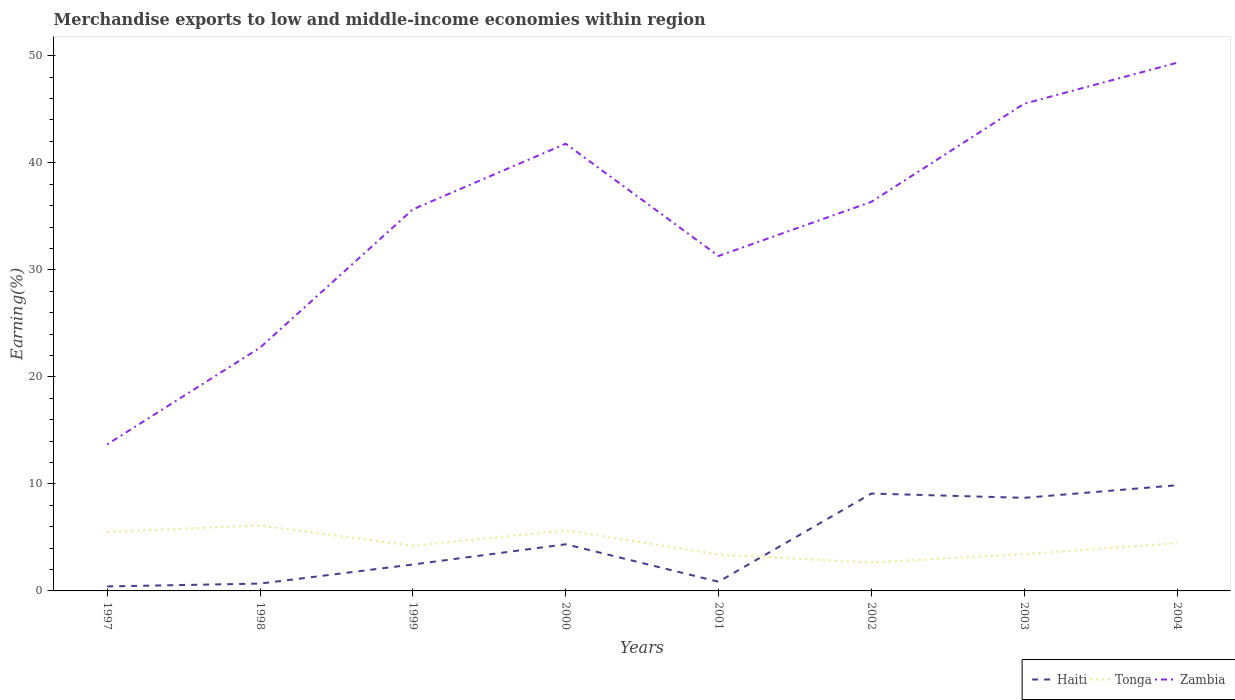Does the line corresponding to Tonga intersect with the line corresponding to Zambia?
Ensure brevity in your answer.  No. Is the number of lines equal to the number of legend labels?
Provide a short and direct response. Yes. Across all years, what is the maximum percentage of amount earned from merchandise exports in Tonga?
Give a very brief answer. 2.65. In which year was the percentage of amount earned from merchandise exports in Tonga maximum?
Make the answer very short. 2002. What is the total percentage of amount earned from merchandise exports in Haiti in the graph?
Ensure brevity in your answer.  -9.19. What is the difference between the highest and the second highest percentage of amount earned from merchandise exports in Haiti?
Give a very brief answer. 9.46. How many lines are there?
Offer a very short reply. 3. How many years are there in the graph?
Your answer should be very brief. 8. What is the difference between two consecutive major ticks on the Y-axis?
Keep it short and to the point. 10. Are the values on the major ticks of Y-axis written in scientific E-notation?
Make the answer very short. No. Where does the legend appear in the graph?
Give a very brief answer. Bottom right. How many legend labels are there?
Keep it short and to the point. 3. How are the legend labels stacked?
Your answer should be compact. Horizontal. What is the title of the graph?
Ensure brevity in your answer.  Merchandise exports to low and middle-income economies within region. Does "United Arab Emirates" appear as one of the legend labels in the graph?
Offer a very short reply. No. What is the label or title of the X-axis?
Your answer should be very brief. Years. What is the label or title of the Y-axis?
Ensure brevity in your answer.  Earning(%). What is the Earning(%) of Haiti in 1997?
Ensure brevity in your answer.  0.42. What is the Earning(%) of Tonga in 1997?
Provide a short and direct response. 5.51. What is the Earning(%) of Zambia in 1997?
Ensure brevity in your answer.  13.69. What is the Earning(%) of Haiti in 1998?
Provide a succinct answer. 0.69. What is the Earning(%) in Tonga in 1998?
Ensure brevity in your answer.  6.12. What is the Earning(%) in Zambia in 1998?
Offer a terse response. 22.73. What is the Earning(%) in Haiti in 1999?
Make the answer very short. 2.47. What is the Earning(%) of Tonga in 1999?
Provide a short and direct response. 4.22. What is the Earning(%) of Zambia in 1999?
Give a very brief answer. 35.65. What is the Earning(%) of Haiti in 2000?
Your answer should be compact. 4.36. What is the Earning(%) in Tonga in 2000?
Your answer should be very brief. 5.66. What is the Earning(%) of Zambia in 2000?
Your answer should be very brief. 41.78. What is the Earning(%) in Haiti in 2001?
Your response must be concise. 0.86. What is the Earning(%) in Tonga in 2001?
Provide a short and direct response. 3.4. What is the Earning(%) of Zambia in 2001?
Your response must be concise. 31.29. What is the Earning(%) of Haiti in 2002?
Your answer should be compact. 9.1. What is the Earning(%) of Tonga in 2002?
Provide a succinct answer. 2.65. What is the Earning(%) in Zambia in 2002?
Provide a succinct answer. 36.35. What is the Earning(%) in Haiti in 2003?
Offer a very short reply. 8.7. What is the Earning(%) in Tonga in 2003?
Provide a succinct answer. 3.44. What is the Earning(%) in Zambia in 2003?
Your response must be concise. 45.52. What is the Earning(%) of Haiti in 2004?
Your answer should be very brief. 9.87. What is the Earning(%) in Tonga in 2004?
Your response must be concise. 4.46. What is the Earning(%) of Zambia in 2004?
Your response must be concise. 49.34. Across all years, what is the maximum Earning(%) in Haiti?
Ensure brevity in your answer.  9.87. Across all years, what is the maximum Earning(%) in Tonga?
Your answer should be compact. 6.12. Across all years, what is the maximum Earning(%) of Zambia?
Your response must be concise. 49.34. Across all years, what is the minimum Earning(%) of Haiti?
Provide a succinct answer. 0.42. Across all years, what is the minimum Earning(%) in Tonga?
Your response must be concise. 2.65. Across all years, what is the minimum Earning(%) of Zambia?
Provide a short and direct response. 13.69. What is the total Earning(%) of Haiti in the graph?
Your response must be concise. 36.46. What is the total Earning(%) of Tonga in the graph?
Offer a terse response. 35.46. What is the total Earning(%) in Zambia in the graph?
Your response must be concise. 276.35. What is the difference between the Earning(%) of Haiti in 1997 and that in 1998?
Give a very brief answer. -0.27. What is the difference between the Earning(%) of Tonga in 1997 and that in 1998?
Give a very brief answer. -0.62. What is the difference between the Earning(%) in Zambia in 1997 and that in 1998?
Give a very brief answer. -9.04. What is the difference between the Earning(%) in Haiti in 1997 and that in 1999?
Offer a terse response. -2.05. What is the difference between the Earning(%) of Tonga in 1997 and that in 1999?
Give a very brief answer. 1.29. What is the difference between the Earning(%) in Zambia in 1997 and that in 1999?
Provide a short and direct response. -21.96. What is the difference between the Earning(%) of Haiti in 1997 and that in 2000?
Offer a terse response. -3.94. What is the difference between the Earning(%) in Tonga in 1997 and that in 2000?
Ensure brevity in your answer.  -0.15. What is the difference between the Earning(%) in Zambia in 1997 and that in 2000?
Ensure brevity in your answer.  -28.09. What is the difference between the Earning(%) in Haiti in 1997 and that in 2001?
Offer a very short reply. -0.44. What is the difference between the Earning(%) in Tonga in 1997 and that in 2001?
Ensure brevity in your answer.  2.1. What is the difference between the Earning(%) of Zambia in 1997 and that in 2001?
Offer a terse response. -17.6. What is the difference between the Earning(%) in Haiti in 1997 and that in 2002?
Make the answer very short. -8.68. What is the difference between the Earning(%) of Tonga in 1997 and that in 2002?
Your answer should be compact. 2.86. What is the difference between the Earning(%) of Zambia in 1997 and that in 2002?
Ensure brevity in your answer.  -22.66. What is the difference between the Earning(%) of Haiti in 1997 and that in 2003?
Provide a succinct answer. -8.28. What is the difference between the Earning(%) in Tonga in 1997 and that in 2003?
Keep it short and to the point. 2.07. What is the difference between the Earning(%) in Zambia in 1997 and that in 2003?
Offer a very short reply. -31.83. What is the difference between the Earning(%) of Haiti in 1997 and that in 2004?
Your answer should be very brief. -9.46. What is the difference between the Earning(%) of Tonga in 1997 and that in 2004?
Give a very brief answer. 1.05. What is the difference between the Earning(%) of Zambia in 1997 and that in 2004?
Your answer should be compact. -35.66. What is the difference between the Earning(%) in Haiti in 1998 and that in 1999?
Provide a succinct answer. -1.78. What is the difference between the Earning(%) in Tonga in 1998 and that in 1999?
Your answer should be very brief. 1.9. What is the difference between the Earning(%) of Zambia in 1998 and that in 1999?
Offer a very short reply. -12.92. What is the difference between the Earning(%) in Haiti in 1998 and that in 2000?
Keep it short and to the point. -3.67. What is the difference between the Earning(%) of Tonga in 1998 and that in 2000?
Ensure brevity in your answer.  0.47. What is the difference between the Earning(%) of Zambia in 1998 and that in 2000?
Your answer should be very brief. -19.05. What is the difference between the Earning(%) in Haiti in 1998 and that in 2001?
Offer a very short reply. -0.17. What is the difference between the Earning(%) of Tonga in 1998 and that in 2001?
Your answer should be very brief. 2.72. What is the difference between the Earning(%) of Zambia in 1998 and that in 2001?
Your response must be concise. -8.57. What is the difference between the Earning(%) in Haiti in 1998 and that in 2002?
Offer a very short reply. -8.41. What is the difference between the Earning(%) of Tonga in 1998 and that in 2002?
Make the answer very short. 3.47. What is the difference between the Earning(%) in Zambia in 1998 and that in 2002?
Provide a short and direct response. -13.62. What is the difference between the Earning(%) in Haiti in 1998 and that in 2003?
Make the answer very short. -8.01. What is the difference between the Earning(%) of Tonga in 1998 and that in 2003?
Ensure brevity in your answer.  2.68. What is the difference between the Earning(%) in Zambia in 1998 and that in 2003?
Provide a succinct answer. -22.79. What is the difference between the Earning(%) in Haiti in 1998 and that in 2004?
Your response must be concise. -9.19. What is the difference between the Earning(%) in Tonga in 1998 and that in 2004?
Your answer should be compact. 1.66. What is the difference between the Earning(%) of Zambia in 1998 and that in 2004?
Make the answer very short. -26.62. What is the difference between the Earning(%) of Haiti in 1999 and that in 2000?
Provide a short and direct response. -1.89. What is the difference between the Earning(%) in Tonga in 1999 and that in 2000?
Your response must be concise. -1.44. What is the difference between the Earning(%) in Zambia in 1999 and that in 2000?
Ensure brevity in your answer.  -6.13. What is the difference between the Earning(%) of Haiti in 1999 and that in 2001?
Your answer should be very brief. 1.61. What is the difference between the Earning(%) in Tonga in 1999 and that in 2001?
Keep it short and to the point. 0.82. What is the difference between the Earning(%) of Zambia in 1999 and that in 2001?
Give a very brief answer. 4.36. What is the difference between the Earning(%) in Haiti in 1999 and that in 2002?
Offer a very short reply. -6.63. What is the difference between the Earning(%) of Tonga in 1999 and that in 2002?
Offer a terse response. 1.57. What is the difference between the Earning(%) in Zambia in 1999 and that in 2002?
Offer a very short reply. -0.7. What is the difference between the Earning(%) of Haiti in 1999 and that in 2003?
Offer a very short reply. -6.23. What is the difference between the Earning(%) in Tonga in 1999 and that in 2003?
Keep it short and to the point. 0.78. What is the difference between the Earning(%) in Zambia in 1999 and that in 2003?
Make the answer very short. -9.87. What is the difference between the Earning(%) of Haiti in 1999 and that in 2004?
Offer a terse response. -7.41. What is the difference between the Earning(%) in Tonga in 1999 and that in 2004?
Provide a short and direct response. -0.24. What is the difference between the Earning(%) of Zambia in 1999 and that in 2004?
Provide a short and direct response. -13.7. What is the difference between the Earning(%) of Haiti in 2000 and that in 2001?
Your answer should be very brief. 3.5. What is the difference between the Earning(%) in Tonga in 2000 and that in 2001?
Keep it short and to the point. 2.25. What is the difference between the Earning(%) of Zambia in 2000 and that in 2001?
Give a very brief answer. 10.49. What is the difference between the Earning(%) of Haiti in 2000 and that in 2002?
Your answer should be compact. -4.74. What is the difference between the Earning(%) of Tonga in 2000 and that in 2002?
Make the answer very short. 3.01. What is the difference between the Earning(%) in Zambia in 2000 and that in 2002?
Your answer should be very brief. 5.43. What is the difference between the Earning(%) in Haiti in 2000 and that in 2003?
Provide a succinct answer. -4.34. What is the difference between the Earning(%) of Tonga in 2000 and that in 2003?
Provide a short and direct response. 2.22. What is the difference between the Earning(%) of Zambia in 2000 and that in 2003?
Your response must be concise. -3.74. What is the difference between the Earning(%) of Haiti in 2000 and that in 2004?
Keep it short and to the point. -5.52. What is the difference between the Earning(%) of Tonga in 2000 and that in 2004?
Your response must be concise. 1.2. What is the difference between the Earning(%) of Zambia in 2000 and that in 2004?
Make the answer very short. -7.57. What is the difference between the Earning(%) of Haiti in 2001 and that in 2002?
Your answer should be compact. -8.24. What is the difference between the Earning(%) in Tonga in 2001 and that in 2002?
Offer a very short reply. 0.75. What is the difference between the Earning(%) of Zambia in 2001 and that in 2002?
Keep it short and to the point. -5.06. What is the difference between the Earning(%) in Haiti in 2001 and that in 2003?
Your answer should be very brief. -7.84. What is the difference between the Earning(%) in Tonga in 2001 and that in 2003?
Offer a very short reply. -0.04. What is the difference between the Earning(%) of Zambia in 2001 and that in 2003?
Your response must be concise. -14.23. What is the difference between the Earning(%) in Haiti in 2001 and that in 2004?
Your answer should be compact. -9.02. What is the difference between the Earning(%) of Tonga in 2001 and that in 2004?
Keep it short and to the point. -1.06. What is the difference between the Earning(%) in Zambia in 2001 and that in 2004?
Your response must be concise. -18.05. What is the difference between the Earning(%) of Haiti in 2002 and that in 2003?
Provide a short and direct response. 0.4. What is the difference between the Earning(%) in Tonga in 2002 and that in 2003?
Ensure brevity in your answer.  -0.79. What is the difference between the Earning(%) of Zambia in 2002 and that in 2003?
Your response must be concise. -9.17. What is the difference between the Earning(%) of Haiti in 2002 and that in 2004?
Offer a terse response. -0.78. What is the difference between the Earning(%) in Tonga in 2002 and that in 2004?
Ensure brevity in your answer.  -1.81. What is the difference between the Earning(%) of Zambia in 2002 and that in 2004?
Offer a terse response. -12.99. What is the difference between the Earning(%) of Haiti in 2003 and that in 2004?
Make the answer very short. -1.18. What is the difference between the Earning(%) in Tonga in 2003 and that in 2004?
Make the answer very short. -1.02. What is the difference between the Earning(%) in Zambia in 2003 and that in 2004?
Make the answer very short. -3.82. What is the difference between the Earning(%) of Haiti in 1997 and the Earning(%) of Tonga in 1998?
Keep it short and to the point. -5.7. What is the difference between the Earning(%) in Haiti in 1997 and the Earning(%) in Zambia in 1998?
Offer a very short reply. -22.31. What is the difference between the Earning(%) of Tonga in 1997 and the Earning(%) of Zambia in 1998?
Offer a terse response. -17.22. What is the difference between the Earning(%) in Haiti in 1997 and the Earning(%) in Tonga in 1999?
Ensure brevity in your answer.  -3.8. What is the difference between the Earning(%) in Haiti in 1997 and the Earning(%) in Zambia in 1999?
Ensure brevity in your answer.  -35.23. What is the difference between the Earning(%) in Tonga in 1997 and the Earning(%) in Zambia in 1999?
Keep it short and to the point. -30.14. What is the difference between the Earning(%) of Haiti in 1997 and the Earning(%) of Tonga in 2000?
Provide a short and direct response. -5.24. What is the difference between the Earning(%) in Haiti in 1997 and the Earning(%) in Zambia in 2000?
Offer a very short reply. -41.36. What is the difference between the Earning(%) of Tonga in 1997 and the Earning(%) of Zambia in 2000?
Your response must be concise. -36.27. What is the difference between the Earning(%) of Haiti in 1997 and the Earning(%) of Tonga in 2001?
Offer a terse response. -2.98. What is the difference between the Earning(%) in Haiti in 1997 and the Earning(%) in Zambia in 2001?
Your response must be concise. -30.87. What is the difference between the Earning(%) in Tonga in 1997 and the Earning(%) in Zambia in 2001?
Give a very brief answer. -25.79. What is the difference between the Earning(%) of Haiti in 1997 and the Earning(%) of Tonga in 2002?
Offer a terse response. -2.23. What is the difference between the Earning(%) of Haiti in 1997 and the Earning(%) of Zambia in 2002?
Your response must be concise. -35.93. What is the difference between the Earning(%) in Tonga in 1997 and the Earning(%) in Zambia in 2002?
Provide a short and direct response. -30.84. What is the difference between the Earning(%) of Haiti in 1997 and the Earning(%) of Tonga in 2003?
Your answer should be compact. -3.02. What is the difference between the Earning(%) in Haiti in 1997 and the Earning(%) in Zambia in 2003?
Provide a succinct answer. -45.1. What is the difference between the Earning(%) of Tonga in 1997 and the Earning(%) of Zambia in 2003?
Your response must be concise. -40.01. What is the difference between the Earning(%) in Haiti in 1997 and the Earning(%) in Tonga in 2004?
Offer a very short reply. -4.04. What is the difference between the Earning(%) in Haiti in 1997 and the Earning(%) in Zambia in 2004?
Offer a very short reply. -48.93. What is the difference between the Earning(%) of Tonga in 1997 and the Earning(%) of Zambia in 2004?
Give a very brief answer. -43.84. What is the difference between the Earning(%) of Haiti in 1998 and the Earning(%) of Tonga in 1999?
Your answer should be very brief. -3.53. What is the difference between the Earning(%) in Haiti in 1998 and the Earning(%) in Zambia in 1999?
Offer a very short reply. -34.96. What is the difference between the Earning(%) of Tonga in 1998 and the Earning(%) of Zambia in 1999?
Ensure brevity in your answer.  -29.53. What is the difference between the Earning(%) of Haiti in 1998 and the Earning(%) of Tonga in 2000?
Your response must be concise. -4.97. What is the difference between the Earning(%) in Haiti in 1998 and the Earning(%) in Zambia in 2000?
Provide a short and direct response. -41.09. What is the difference between the Earning(%) in Tonga in 1998 and the Earning(%) in Zambia in 2000?
Keep it short and to the point. -35.66. What is the difference between the Earning(%) of Haiti in 1998 and the Earning(%) of Tonga in 2001?
Keep it short and to the point. -2.72. What is the difference between the Earning(%) of Haiti in 1998 and the Earning(%) of Zambia in 2001?
Give a very brief answer. -30.61. What is the difference between the Earning(%) in Tonga in 1998 and the Earning(%) in Zambia in 2001?
Make the answer very short. -25.17. What is the difference between the Earning(%) in Haiti in 1998 and the Earning(%) in Tonga in 2002?
Make the answer very short. -1.97. What is the difference between the Earning(%) in Haiti in 1998 and the Earning(%) in Zambia in 2002?
Your answer should be very brief. -35.66. What is the difference between the Earning(%) of Tonga in 1998 and the Earning(%) of Zambia in 2002?
Give a very brief answer. -30.23. What is the difference between the Earning(%) in Haiti in 1998 and the Earning(%) in Tonga in 2003?
Your answer should be very brief. -2.75. What is the difference between the Earning(%) in Haiti in 1998 and the Earning(%) in Zambia in 2003?
Provide a short and direct response. -44.84. What is the difference between the Earning(%) in Tonga in 1998 and the Earning(%) in Zambia in 2003?
Your response must be concise. -39.4. What is the difference between the Earning(%) of Haiti in 1998 and the Earning(%) of Tonga in 2004?
Your answer should be compact. -3.77. What is the difference between the Earning(%) of Haiti in 1998 and the Earning(%) of Zambia in 2004?
Your response must be concise. -48.66. What is the difference between the Earning(%) in Tonga in 1998 and the Earning(%) in Zambia in 2004?
Offer a terse response. -43.22. What is the difference between the Earning(%) of Haiti in 1999 and the Earning(%) of Tonga in 2000?
Offer a very short reply. -3.19. What is the difference between the Earning(%) in Haiti in 1999 and the Earning(%) in Zambia in 2000?
Provide a succinct answer. -39.31. What is the difference between the Earning(%) of Tonga in 1999 and the Earning(%) of Zambia in 2000?
Give a very brief answer. -37.56. What is the difference between the Earning(%) in Haiti in 1999 and the Earning(%) in Tonga in 2001?
Make the answer very short. -0.93. What is the difference between the Earning(%) of Haiti in 1999 and the Earning(%) of Zambia in 2001?
Offer a terse response. -28.82. What is the difference between the Earning(%) of Tonga in 1999 and the Earning(%) of Zambia in 2001?
Give a very brief answer. -27.07. What is the difference between the Earning(%) of Haiti in 1999 and the Earning(%) of Tonga in 2002?
Make the answer very short. -0.18. What is the difference between the Earning(%) in Haiti in 1999 and the Earning(%) in Zambia in 2002?
Ensure brevity in your answer.  -33.88. What is the difference between the Earning(%) of Tonga in 1999 and the Earning(%) of Zambia in 2002?
Keep it short and to the point. -32.13. What is the difference between the Earning(%) in Haiti in 1999 and the Earning(%) in Tonga in 2003?
Make the answer very short. -0.97. What is the difference between the Earning(%) in Haiti in 1999 and the Earning(%) in Zambia in 2003?
Your response must be concise. -43.05. What is the difference between the Earning(%) of Tonga in 1999 and the Earning(%) of Zambia in 2003?
Your answer should be compact. -41.3. What is the difference between the Earning(%) of Haiti in 1999 and the Earning(%) of Tonga in 2004?
Provide a short and direct response. -1.99. What is the difference between the Earning(%) in Haiti in 1999 and the Earning(%) in Zambia in 2004?
Offer a very short reply. -46.88. What is the difference between the Earning(%) in Tonga in 1999 and the Earning(%) in Zambia in 2004?
Provide a short and direct response. -45.13. What is the difference between the Earning(%) of Haiti in 2000 and the Earning(%) of Tonga in 2001?
Offer a very short reply. 0.96. What is the difference between the Earning(%) in Haiti in 2000 and the Earning(%) in Zambia in 2001?
Make the answer very short. -26.93. What is the difference between the Earning(%) of Tonga in 2000 and the Earning(%) of Zambia in 2001?
Make the answer very short. -25.64. What is the difference between the Earning(%) of Haiti in 2000 and the Earning(%) of Tonga in 2002?
Offer a very short reply. 1.71. What is the difference between the Earning(%) in Haiti in 2000 and the Earning(%) in Zambia in 2002?
Your answer should be very brief. -31.99. What is the difference between the Earning(%) in Tonga in 2000 and the Earning(%) in Zambia in 2002?
Provide a short and direct response. -30.69. What is the difference between the Earning(%) of Haiti in 2000 and the Earning(%) of Tonga in 2003?
Offer a terse response. 0.92. What is the difference between the Earning(%) in Haiti in 2000 and the Earning(%) in Zambia in 2003?
Make the answer very short. -41.16. What is the difference between the Earning(%) of Tonga in 2000 and the Earning(%) of Zambia in 2003?
Give a very brief answer. -39.86. What is the difference between the Earning(%) of Haiti in 2000 and the Earning(%) of Tonga in 2004?
Your answer should be compact. -0.1. What is the difference between the Earning(%) in Haiti in 2000 and the Earning(%) in Zambia in 2004?
Make the answer very short. -44.99. What is the difference between the Earning(%) of Tonga in 2000 and the Earning(%) of Zambia in 2004?
Provide a succinct answer. -43.69. What is the difference between the Earning(%) of Haiti in 2001 and the Earning(%) of Tonga in 2002?
Your answer should be very brief. -1.79. What is the difference between the Earning(%) of Haiti in 2001 and the Earning(%) of Zambia in 2002?
Offer a terse response. -35.49. What is the difference between the Earning(%) of Tonga in 2001 and the Earning(%) of Zambia in 2002?
Your answer should be compact. -32.95. What is the difference between the Earning(%) in Haiti in 2001 and the Earning(%) in Tonga in 2003?
Offer a very short reply. -2.58. What is the difference between the Earning(%) in Haiti in 2001 and the Earning(%) in Zambia in 2003?
Make the answer very short. -44.66. What is the difference between the Earning(%) of Tonga in 2001 and the Earning(%) of Zambia in 2003?
Your answer should be very brief. -42.12. What is the difference between the Earning(%) in Haiti in 2001 and the Earning(%) in Tonga in 2004?
Offer a very short reply. -3.6. What is the difference between the Earning(%) of Haiti in 2001 and the Earning(%) of Zambia in 2004?
Keep it short and to the point. -48.49. What is the difference between the Earning(%) in Tonga in 2001 and the Earning(%) in Zambia in 2004?
Your response must be concise. -45.94. What is the difference between the Earning(%) in Haiti in 2002 and the Earning(%) in Tonga in 2003?
Offer a terse response. 5.66. What is the difference between the Earning(%) of Haiti in 2002 and the Earning(%) of Zambia in 2003?
Offer a terse response. -36.42. What is the difference between the Earning(%) in Tonga in 2002 and the Earning(%) in Zambia in 2003?
Your answer should be compact. -42.87. What is the difference between the Earning(%) in Haiti in 2002 and the Earning(%) in Tonga in 2004?
Ensure brevity in your answer.  4.64. What is the difference between the Earning(%) of Haiti in 2002 and the Earning(%) of Zambia in 2004?
Your response must be concise. -40.25. What is the difference between the Earning(%) in Tonga in 2002 and the Earning(%) in Zambia in 2004?
Provide a succinct answer. -46.69. What is the difference between the Earning(%) in Haiti in 2003 and the Earning(%) in Tonga in 2004?
Provide a succinct answer. 4.24. What is the difference between the Earning(%) of Haiti in 2003 and the Earning(%) of Zambia in 2004?
Provide a succinct answer. -40.65. What is the difference between the Earning(%) in Tonga in 2003 and the Earning(%) in Zambia in 2004?
Your response must be concise. -45.91. What is the average Earning(%) of Haiti per year?
Offer a very short reply. 4.56. What is the average Earning(%) in Tonga per year?
Give a very brief answer. 4.43. What is the average Earning(%) in Zambia per year?
Provide a succinct answer. 34.54. In the year 1997, what is the difference between the Earning(%) of Haiti and Earning(%) of Tonga?
Provide a short and direct response. -5.09. In the year 1997, what is the difference between the Earning(%) in Haiti and Earning(%) in Zambia?
Your answer should be compact. -13.27. In the year 1997, what is the difference between the Earning(%) of Tonga and Earning(%) of Zambia?
Provide a short and direct response. -8.18. In the year 1998, what is the difference between the Earning(%) in Haiti and Earning(%) in Tonga?
Make the answer very short. -5.44. In the year 1998, what is the difference between the Earning(%) of Haiti and Earning(%) of Zambia?
Make the answer very short. -22.04. In the year 1998, what is the difference between the Earning(%) of Tonga and Earning(%) of Zambia?
Your answer should be very brief. -16.6. In the year 1999, what is the difference between the Earning(%) of Haiti and Earning(%) of Tonga?
Offer a terse response. -1.75. In the year 1999, what is the difference between the Earning(%) in Haiti and Earning(%) in Zambia?
Give a very brief answer. -33.18. In the year 1999, what is the difference between the Earning(%) of Tonga and Earning(%) of Zambia?
Keep it short and to the point. -31.43. In the year 2000, what is the difference between the Earning(%) in Haiti and Earning(%) in Tonga?
Your answer should be very brief. -1.3. In the year 2000, what is the difference between the Earning(%) in Haiti and Earning(%) in Zambia?
Your answer should be very brief. -37.42. In the year 2000, what is the difference between the Earning(%) of Tonga and Earning(%) of Zambia?
Make the answer very short. -36.12. In the year 2001, what is the difference between the Earning(%) of Haiti and Earning(%) of Tonga?
Your answer should be very brief. -2.54. In the year 2001, what is the difference between the Earning(%) of Haiti and Earning(%) of Zambia?
Give a very brief answer. -30.43. In the year 2001, what is the difference between the Earning(%) in Tonga and Earning(%) in Zambia?
Ensure brevity in your answer.  -27.89. In the year 2002, what is the difference between the Earning(%) of Haiti and Earning(%) of Tonga?
Provide a short and direct response. 6.45. In the year 2002, what is the difference between the Earning(%) of Haiti and Earning(%) of Zambia?
Your answer should be compact. -27.25. In the year 2002, what is the difference between the Earning(%) of Tonga and Earning(%) of Zambia?
Keep it short and to the point. -33.7. In the year 2003, what is the difference between the Earning(%) in Haiti and Earning(%) in Tonga?
Make the answer very short. 5.26. In the year 2003, what is the difference between the Earning(%) of Haiti and Earning(%) of Zambia?
Your answer should be compact. -36.82. In the year 2003, what is the difference between the Earning(%) of Tonga and Earning(%) of Zambia?
Ensure brevity in your answer.  -42.08. In the year 2004, what is the difference between the Earning(%) of Haiti and Earning(%) of Tonga?
Your answer should be very brief. 5.41. In the year 2004, what is the difference between the Earning(%) of Haiti and Earning(%) of Zambia?
Offer a very short reply. -39.47. In the year 2004, what is the difference between the Earning(%) in Tonga and Earning(%) in Zambia?
Ensure brevity in your answer.  -44.88. What is the ratio of the Earning(%) in Haiti in 1997 to that in 1998?
Provide a short and direct response. 0.61. What is the ratio of the Earning(%) of Tonga in 1997 to that in 1998?
Keep it short and to the point. 0.9. What is the ratio of the Earning(%) of Zambia in 1997 to that in 1998?
Give a very brief answer. 0.6. What is the ratio of the Earning(%) in Haiti in 1997 to that in 1999?
Ensure brevity in your answer.  0.17. What is the ratio of the Earning(%) of Tonga in 1997 to that in 1999?
Provide a succinct answer. 1.31. What is the ratio of the Earning(%) in Zambia in 1997 to that in 1999?
Your response must be concise. 0.38. What is the ratio of the Earning(%) in Haiti in 1997 to that in 2000?
Give a very brief answer. 0.1. What is the ratio of the Earning(%) in Tonga in 1997 to that in 2000?
Make the answer very short. 0.97. What is the ratio of the Earning(%) of Zambia in 1997 to that in 2000?
Ensure brevity in your answer.  0.33. What is the ratio of the Earning(%) in Haiti in 1997 to that in 2001?
Keep it short and to the point. 0.49. What is the ratio of the Earning(%) of Tonga in 1997 to that in 2001?
Your response must be concise. 1.62. What is the ratio of the Earning(%) of Zambia in 1997 to that in 2001?
Your answer should be very brief. 0.44. What is the ratio of the Earning(%) in Haiti in 1997 to that in 2002?
Offer a terse response. 0.05. What is the ratio of the Earning(%) in Tonga in 1997 to that in 2002?
Provide a succinct answer. 2.08. What is the ratio of the Earning(%) of Zambia in 1997 to that in 2002?
Provide a short and direct response. 0.38. What is the ratio of the Earning(%) of Haiti in 1997 to that in 2003?
Ensure brevity in your answer.  0.05. What is the ratio of the Earning(%) in Tonga in 1997 to that in 2003?
Offer a very short reply. 1.6. What is the ratio of the Earning(%) of Zambia in 1997 to that in 2003?
Offer a terse response. 0.3. What is the ratio of the Earning(%) of Haiti in 1997 to that in 2004?
Ensure brevity in your answer.  0.04. What is the ratio of the Earning(%) in Tonga in 1997 to that in 2004?
Your response must be concise. 1.23. What is the ratio of the Earning(%) in Zambia in 1997 to that in 2004?
Your answer should be very brief. 0.28. What is the ratio of the Earning(%) in Haiti in 1998 to that in 1999?
Offer a very short reply. 0.28. What is the ratio of the Earning(%) in Tonga in 1998 to that in 1999?
Ensure brevity in your answer.  1.45. What is the ratio of the Earning(%) in Zambia in 1998 to that in 1999?
Provide a short and direct response. 0.64. What is the ratio of the Earning(%) in Haiti in 1998 to that in 2000?
Offer a very short reply. 0.16. What is the ratio of the Earning(%) of Tonga in 1998 to that in 2000?
Offer a very short reply. 1.08. What is the ratio of the Earning(%) of Zambia in 1998 to that in 2000?
Give a very brief answer. 0.54. What is the ratio of the Earning(%) in Haiti in 1998 to that in 2001?
Your response must be concise. 0.8. What is the ratio of the Earning(%) of Tonga in 1998 to that in 2001?
Your response must be concise. 1.8. What is the ratio of the Earning(%) in Zambia in 1998 to that in 2001?
Your answer should be compact. 0.73. What is the ratio of the Earning(%) in Haiti in 1998 to that in 2002?
Offer a terse response. 0.08. What is the ratio of the Earning(%) in Tonga in 1998 to that in 2002?
Your answer should be very brief. 2.31. What is the ratio of the Earning(%) in Zambia in 1998 to that in 2002?
Provide a succinct answer. 0.63. What is the ratio of the Earning(%) in Haiti in 1998 to that in 2003?
Your answer should be compact. 0.08. What is the ratio of the Earning(%) of Tonga in 1998 to that in 2003?
Give a very brief answer. 1.78. What is the ratio of the Earning(%) of Zambia in 1998 to that in 2003?
Offer a terse response. 0.5. What is the ratio of the Earning(%) in Haiti in 1998 to that in 2004?
Offer a terse response. 0.07. What is the ratio of the Earning(%) of Tonga in 1998 to that in 2004?
Your response must be concise. 1.37. What is the ratio of the Earning(%) of Zambia in 1998 to that in 2004?
Provide a short and direct response. 0.46. What is the ratio of the Earning(%) in Haiti in 1999 to that in 2000?
Your answer should be compact. 0.57. What is the ratio of the Earning(%) of Tonga in 1999 to that in 2000?
Your answer should be very brief. 0.75. What is the ratio of the Earning(%) of Zambia in 1999 to that in 2000?
Offer a very short reply. 0.85. What is the ratio of the Earning(%) in Haiti in 1999 to that in 2001?
Give a very brief answer. 2.87. What is the ratio of the Earning(%) of Tonga in 1999 to that in 2001?
Provide a short and direct response. 1.24. What is the ratio of the Earning(%) of Zambia in 1999 to that in 2001?
Your answer should be compact. 1.14. What is the ratio of the Earning(%) of Haiti in 1999 to that in 2002?
Offer a terse response. 0.27. What is the ratio of the Earning(%) of Tonga in 1999 to that in 2002?
Keep it short and to the point. 1.59. What is the ratio of the Earning(%) in Zambia in 1999 to that in 2002?
Offer a terse response. 0.98. What is the ratio of the Earning(%) in Haiti in 1999 to that in 2003?
Your answer should be compact. 0.28. What is the ratio of the Earning(%) of Tonga in 1999 to that in 2003?
Make the answer very short. 1.23. What is the ratio of the Earning(%) of Zambia in 1999 to that in 2003?
Ensure brevity in your answer.  0.78. What is the ratio of the Earning(%) of Haiti in 1999 to that in 2004?
Your answer should be very brief. 0.25. What is the ratio of the Earning(%) of Tonga in 1999 to that in 2004?
Keep it short and to the point. 0.95. What is the ratio of the Earning(%) in Zambia in 1999 to that in 2004?
Keep it short and to the point. 0.72. What is the ratio of the Earning(%) of Haiti in 2000 to that in 2001?
Make the answer very short. 5.07. What is the ratio of the Earning(%) in Tonga in 2000 to that in 2001?
Your response must be concise. 1.66. What is the ratio of the Earning(%) in Zambia in 2000 to that in 2001?
Provide a short and direct response. 1.34. What is the ratio of the Earning(%) of Haiti in 2000 to that in 2002?
Offer a very short reply. 0.48. What is the ratio of the Earning(%) in Tonga in 2000 to that in 2002?
Keep it short and to the point. 2.13. What is the ratio of the Earning(%) in Zambia in 2000 to that in 2002?
Offer a very short reply. 1.15. What is the ratio of the Earning(%) of Haiti in 2000 to that in 2003?
Keep it short and to the point. 0.5. What is the ratio of the Earning(%) of Tonga in 2000 to that in 2003?
Keep it short and to the point. 1.64. What is the ratio of the Earning(%) of Zambia in 2000 to that in 2003?
Provide a succinct answer. 0.92. What is the ratio of the Earning(%) of Haiti in 2000 to that in 2004?
Provide a short and direct response. 0.44. What is the ratio of the Earning(%) of Tonga in 2000 to that in 2004?
Offer a very short reply. 1.27. What is the ratio of the Earning(%) in Zambia in 2000 to that in 2004?
Your answer should be very brief. 0.85. What is the ratio of the Earning(%) in Haiti in 2001 to that in 2002?
Provide a succinct answer. 0.09. What is the ratio of the Earning(%) in Tonga in 2001 to that in 2002?
Provide a succinct answer. 1.28. What is the ratio of the Earning(%) of Zambia in 2001 to that in 2002?
Provide a short and direct response. 0.86. What is the ratio of the Earning(%) in Haiti in 2001 to that in 2003?
Your answer should be very brief. 0.1. What is the ratio of the Earning(%) of Tonga in 2001 to that in 2003?
Offer a very short reply. 0.99. What is the ratio of the Earning(%) of Zambia in 2001 to that in 2003?
Your response must be concise. 0.69. What is the ratio of the Earning(%) in Haiti in 2001 to that in 2004?
Offer a terse response. 0.09. What is the ratio of the Earning(%) in Tonga in 2001 to that in 2004?
Your answer should be very brief. 0.76. What is the ratio of the Earning(%) in Zambia in 2001 to that in 2004?
Provide a succinct answer. 0.63. What is the ratio of the Earning(%) of Haiti in 2002 to that in 2003?
Ensure brevity in your answer.  1.05. What is the ratio of the Earning(%) in Tonga in 2002 to that in 2003?
Your response must be concise. 0.77. What is the ratio of the Earning(%) in Zambia in 2002 to that in 2003?
Your response must be concise. 0.8. What is the ratio of the Earning(%) of Haiti in 2002 to that in 2004?
Ensure brevity in your answer.  0.92. What is the ratio of the Earning(%) in Tonga in 2002 to that in 2004?
Your answer should be very brief. 0.59. What is the ratio of the Earning(%) of Zambia in 2002 to that in 2004?
Provide a short and direct response. 0.74. What is the ratio of the Earning(%) of Haiti in 2003 to that in 2004?
Ensure brevity in your answer.  0.88. What is the ratio of the Earning(%) of Tonga in 2003 to that in 2004?
Keep it short and to the point. 0.77. What is the ratio of the Earning(%) of Zambia in 2003 to that in 2004?
Your answer should be compact. 0.92. What is the difference between the highest and the second highest Earning(%) in Haiti?
Make the answer very short. 0.78. What is the difference between the highest and the second highest Earning(%) in Tonga?
Your response must be concise. 0.47. What is the difference between the highest and the second highest Earning(%) in Zambia?
Give a very brief answer. 3.82. What is the difference between the highest and the lowest Earning(%) of Haiti?
Ensure brevity in your answer.  9.46. What is the difference between the highest and the lowest Earning(%) of Tonga?
Your response must be concise. 3.47. What is the difference between the highest and the lowest Earning(%) in Zambia?
Offer a very short reply. 35.66. 